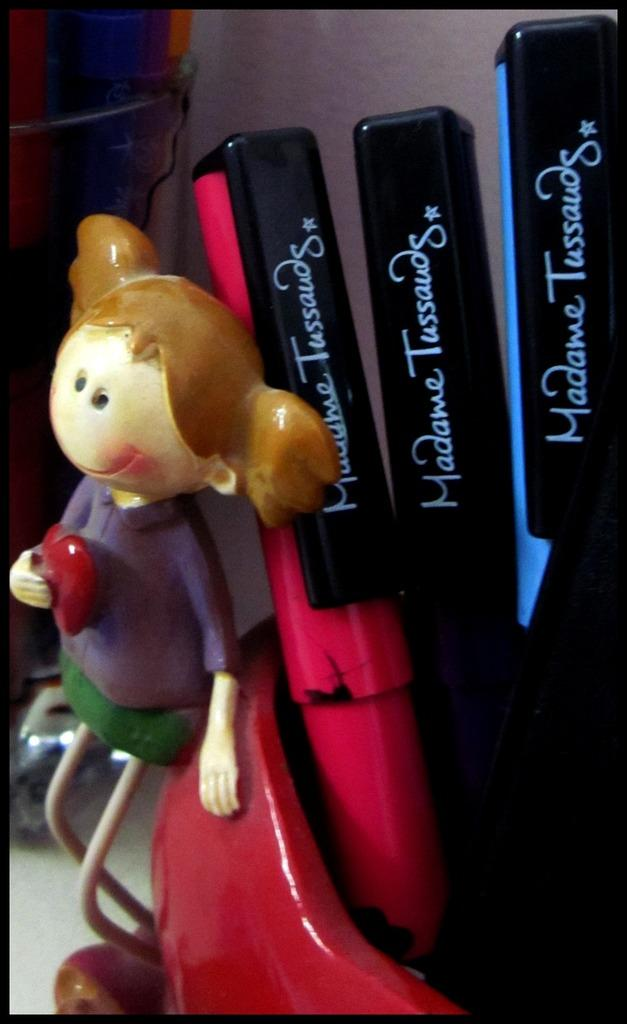<image>
Describe the image concisely. Some Madame Tussauds souvenirs are lined up by a figuring of a girl. 